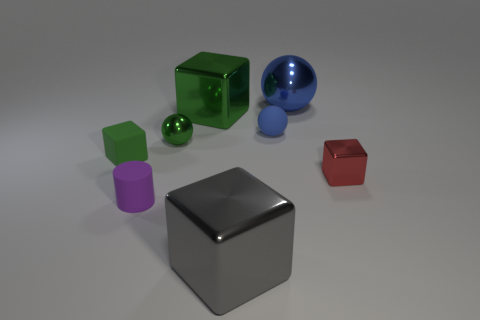The tiny metal cube has what color?
Provide a succinct answer. Red. Does the large metal block that is on the left side of the big gray shiny object have the same color as the tiny matte sphere?
Make the answer very short. No. What number of other objects are the same material as the big gray object?
Give a very brief answer. 4. Is the material of the green block on the right side of the tiny purple rubber thing the same as the purple thing?
Ensure brevity in your answer.  No. There is a blue thing behind the large block that is left of the big shiny object that is in front of the green metal ball; how big is it?
Ensure brevity in your answer.  Large. What number of other things are there of the same color as the rubber cylinder?
Provide a short and direct response. 0. There is a green metal thing that is the same size as the gray metallic block; what is its shape?
Provide a short and direct response. Cube. There is a metal cube that is on the right side of the blue rubber ball; how big is it?
Ensure brevity in your answer.  Small. Is the color of the tiny block that is to the right of the big blue sphere the same as the big thing that is in front of the small blue ball?
Ensure brevity in your answer.  No. There is a small sphere on the right side of the cube that is behind the tiny object that is behind the small green sphere; what is its material?
Make the answer very short. Rubber. 